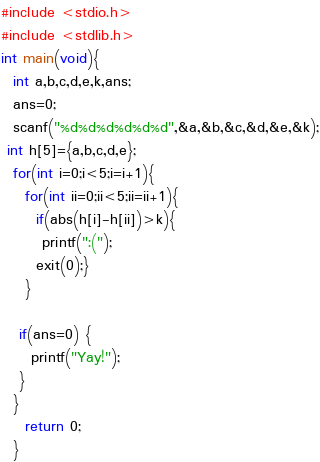Convert code to text. <code><loc_0><loc_0><loc_500><loc_500><_C_>#include <stdio.h>
#include <stdlib.h>
int main(void){
  int a,b,c,d,e,k,ans;
  ans=0;
  scanf("%d%d%d%d%d%d",&a,&b,&c,&d,&e,&k);
 int h[5]={a,b,c,d,e};
  for(int i=0;i<5;i=i+1){
    for(int ii=0;ii<5;ii=ii+1){
      if(abs(h[i]-h[ii])>k){
       printf(":(");
      exit(0);}
    }
  
   if(ans=0) {
     printf("Yay!");
   }
  }
    return 0;
  }</code> 